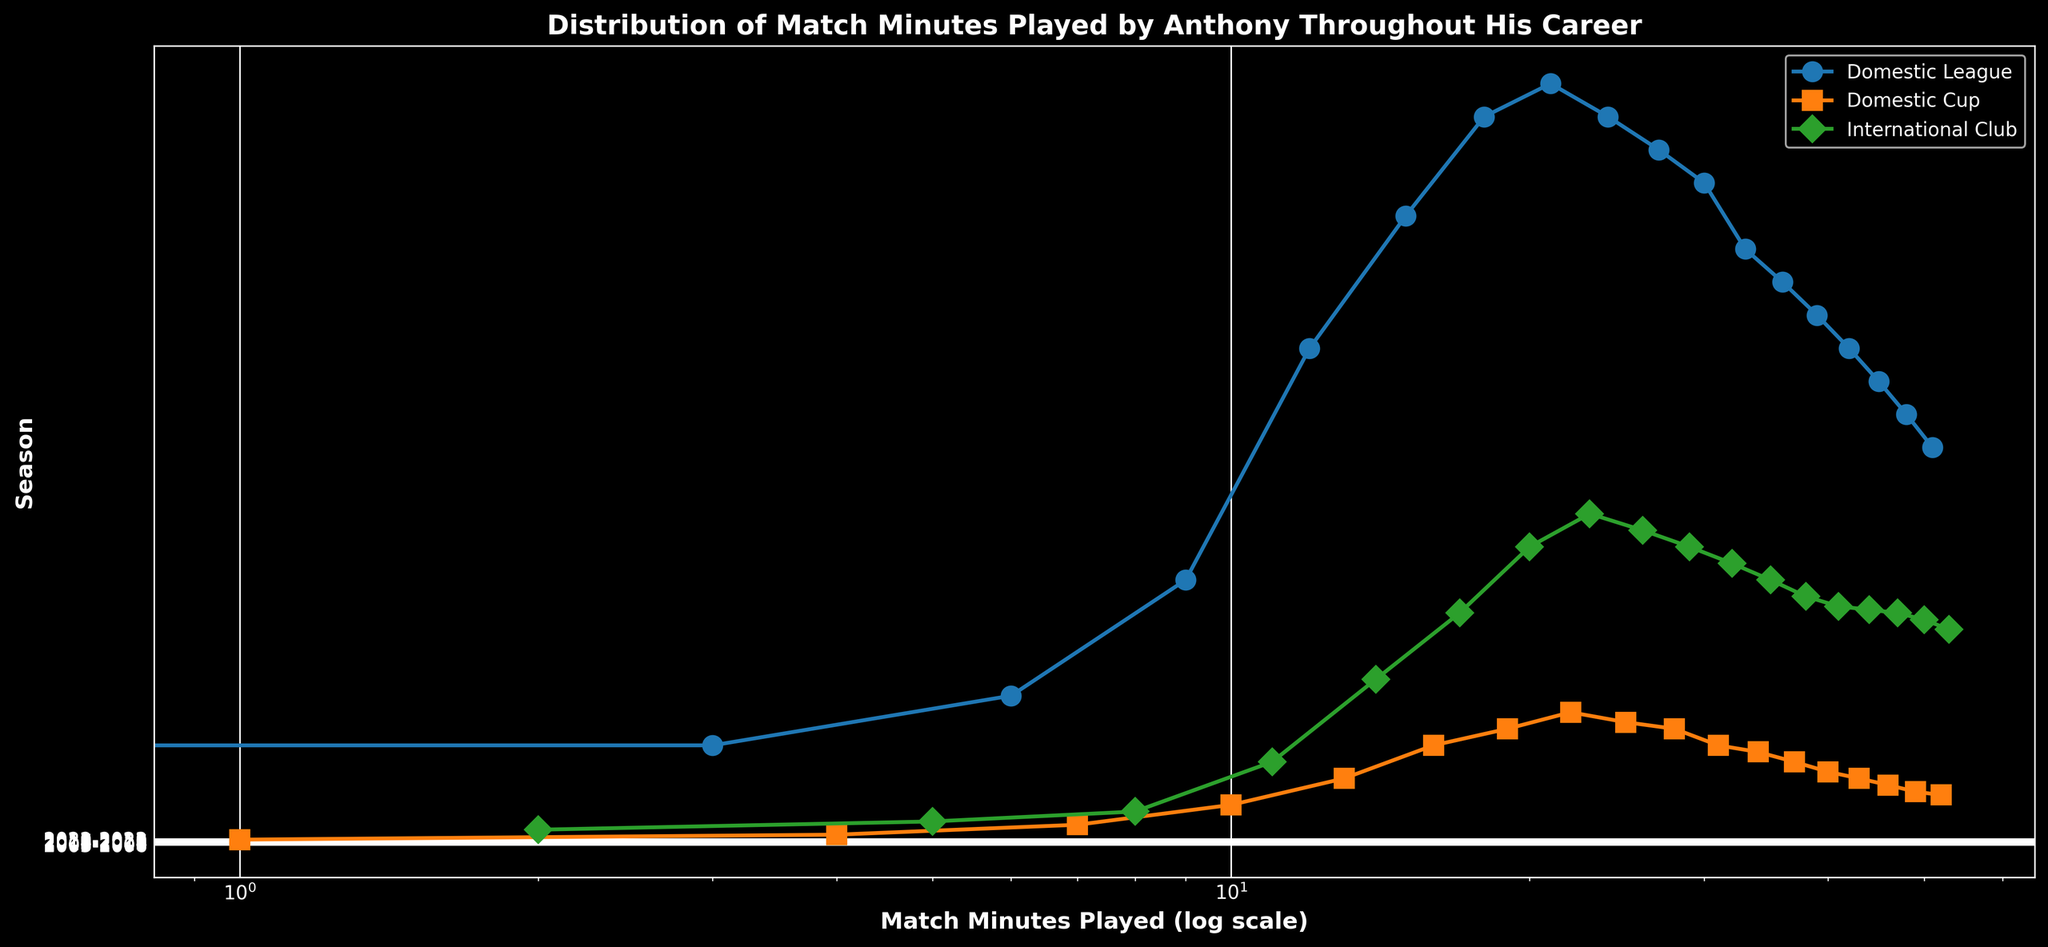How many minutes did Anthony play in the Domestic League during the 2009-2010 season? Look at the 2009-2010 season on the y-axis and find the corresponding value (1500) for Domestic League (marked by circles).
Answer: 1500 Did Anthony play more minutes in International Club tournaments or Domestic Cup tournaments during the 2010-2011 season? Compare the markers for the 2010-2011 season. International Club minutes (700) are shown by green diamonds, while Domestic Cup minutes (300) are shown by orange squares.
Answer: International Club From which season did Anthony start consistently playing over 2000 minutes in Domestic League? Look at the Domestic League markers (blue circles) along the seasons on the y-axis. Anthony started playing over 2000 minutes from the 2011-2012 season.
Answer: 2011-2012 How many total minutes did Anthony play in all tournaments during the 2013-2014 season? Sum the minutes played in Domestic League (2200), Domestic Cup (370), and International Club (950) for the 2013-2014 season. 2200 + 370 + 950 = 3520.
Answer: 3520 What is the trend in minutes played in the Domestic League from the 2015-2016 season to the 2022-2023 season? Observe the blue circles from 2015-2016 to 2022-2023. The minutes played decrease gradually from 2000 to 1200.
Answer: Decreasing Which season did Anthony play the highest number of minutes in International Club tournaments, and how many minutes were played? Look for the highest green diamond marker, which is in the 2012-2013 season with 1000 minutes played.
Answer: 2012-2013, 1000 What is the difference in minutes played between Domestic League and Domestic Cup tournaments in the 2008-2009 season? Subtract the minutes played in Domestic Cup (120) from Domestic League (800) for 2008-2009. 800 - 120 = 680.
Answer: 680 Between the 2017-2018 and 2022-2023 seasons, identify the season with the minimum minutes played in Domestic Cup tournaments. Check the orange square markers for the seasons between 2017-2018 and 2022-2023. The minimum is in the 2022-2023 season with 150 minutes.
Answer: 2022-2023 Which tournament had the most consistent minutes played over the years? Visually assess which type of marker (circle, square, or diamond) shows the least variability across all seasons. Domestic League (blue circles) reflects relative consistency with minor deviations compared to others.
Answer: Domestic League 